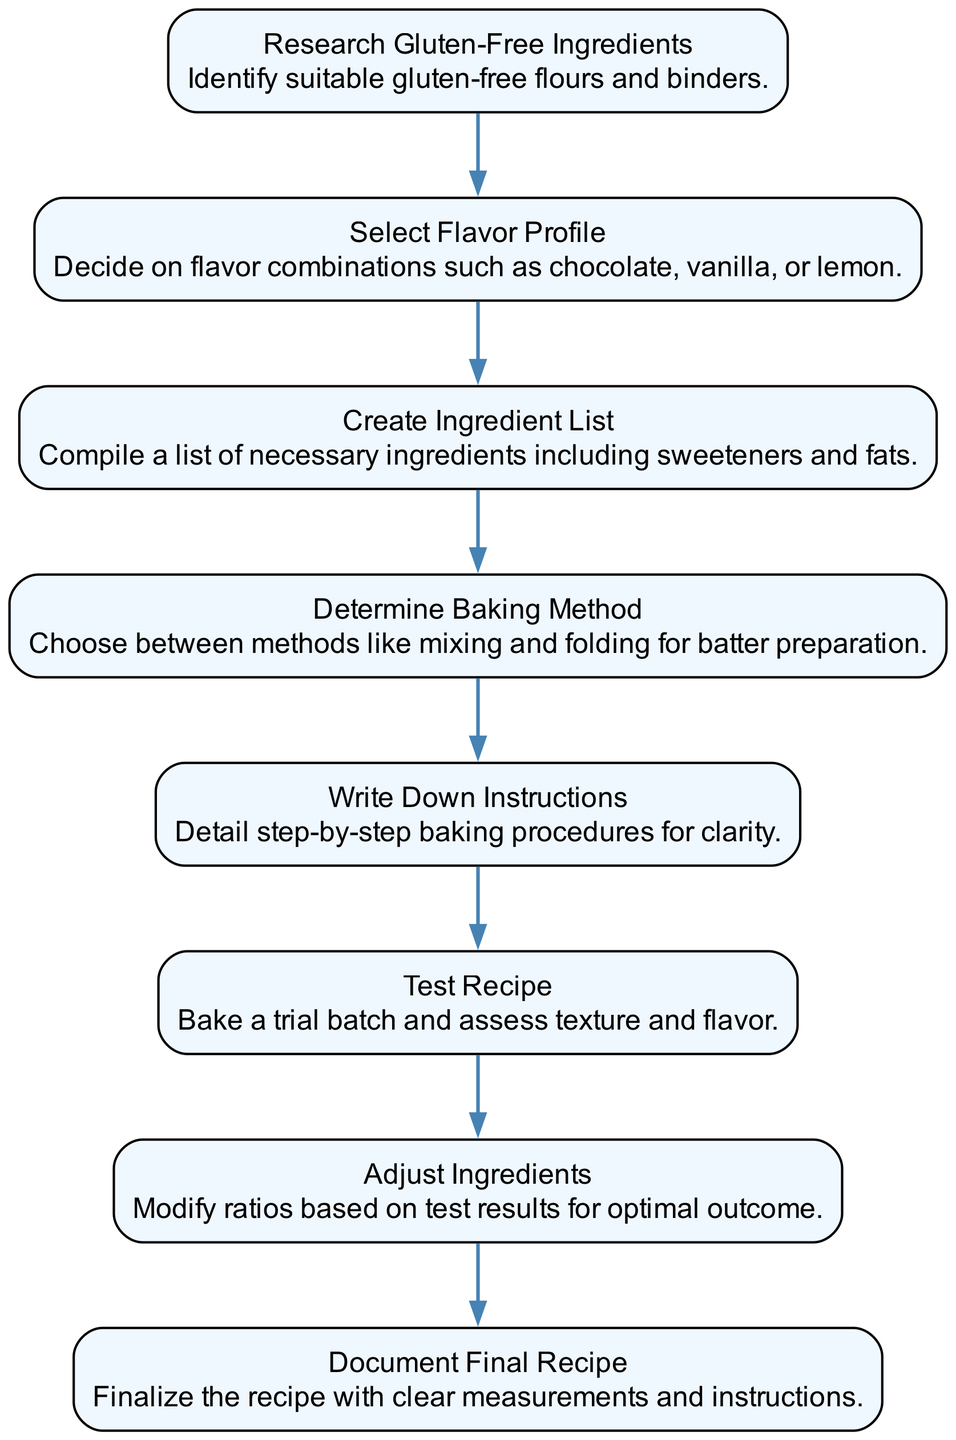What is the first step in the recipe development process? The first step listed in the diagram is "Research Gluten-Free Ingredients," which involves identifying suitable gluten-free flours and binders.
Answer: Research Gluten-Free Ingredients How many steps are there in total? By counting each individual step listed in the diagram, we see there are a total of eight steps outlined for creating the recipe.
Answer: 8 What action is associated with the "Test Recipe" step? The action related to the "Test Recipe" step is "Bake a trial batch and assess texture and flavor," which clarifies what should be done during that step.
Answer: Bake a trial batch and assess texture and flavor Which step comes after "Create Ingredient List"? By reviewing the flow of the diagram, it shows that the step that follows "Create Ingredient List" is "Determine Baking Method."
Answer: Determine Baking Method What is the final step documented in the diagram? The last step outlined in the sequence diagram is "Document Final Recipe," indicating the conclusion of the recipe development process.
Answer: Document Final Recipe Which two steps are connected directly through an edge? The steps "Select Flavor Profile" and "Create Ingredient List" are directly connected as they follow one another in the sequence of the diagram.
Answer: Select Flavor Profile and Create Ingredient List How many actions are described in the sequence diagram? Each of the eight steps has a corresponding action, totaling eight actions present in the sequence for creating the gluten-free cake.
Answer: 8 What is the purpose of the "Adjust Ingredients" step? The purpose of the "Adjust Ingredients" step is to "Modify ratios based on test results for optimal outcome," which aims to refine the recipe following testing.
Answer: Modify ratios based on test results for optimal outcome 